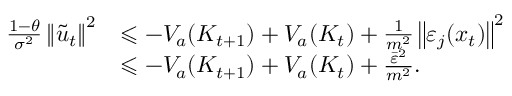Convert formula to latex. <formula><loc_0><loc_0><loc_500><loc_500>\begin{array} { r l } { \frac { 1 - \theta } { \sigma ^ { 2 } } \left \| \tilde { u } _ { t } \right \| ^ { 2 } } & { \leqslant - V _ { a } ( K _ { t + 1 } ) + V _ { a } ( K _ { t } ) + \frac { 1 } { m ^ { 2 } } \left \| \varepsilon _ { j } ( x _ { t } ) \right \| ^ { 2 } } \\ & { \leqslant - V _ { a } ( K _ { t + 1 } ) + V _ { a } ( K _ { t } ) + \frac { \bar { \varepsilon } ^ { 2 } } { m ^ { 2 } } . } \end{array}</formula> 